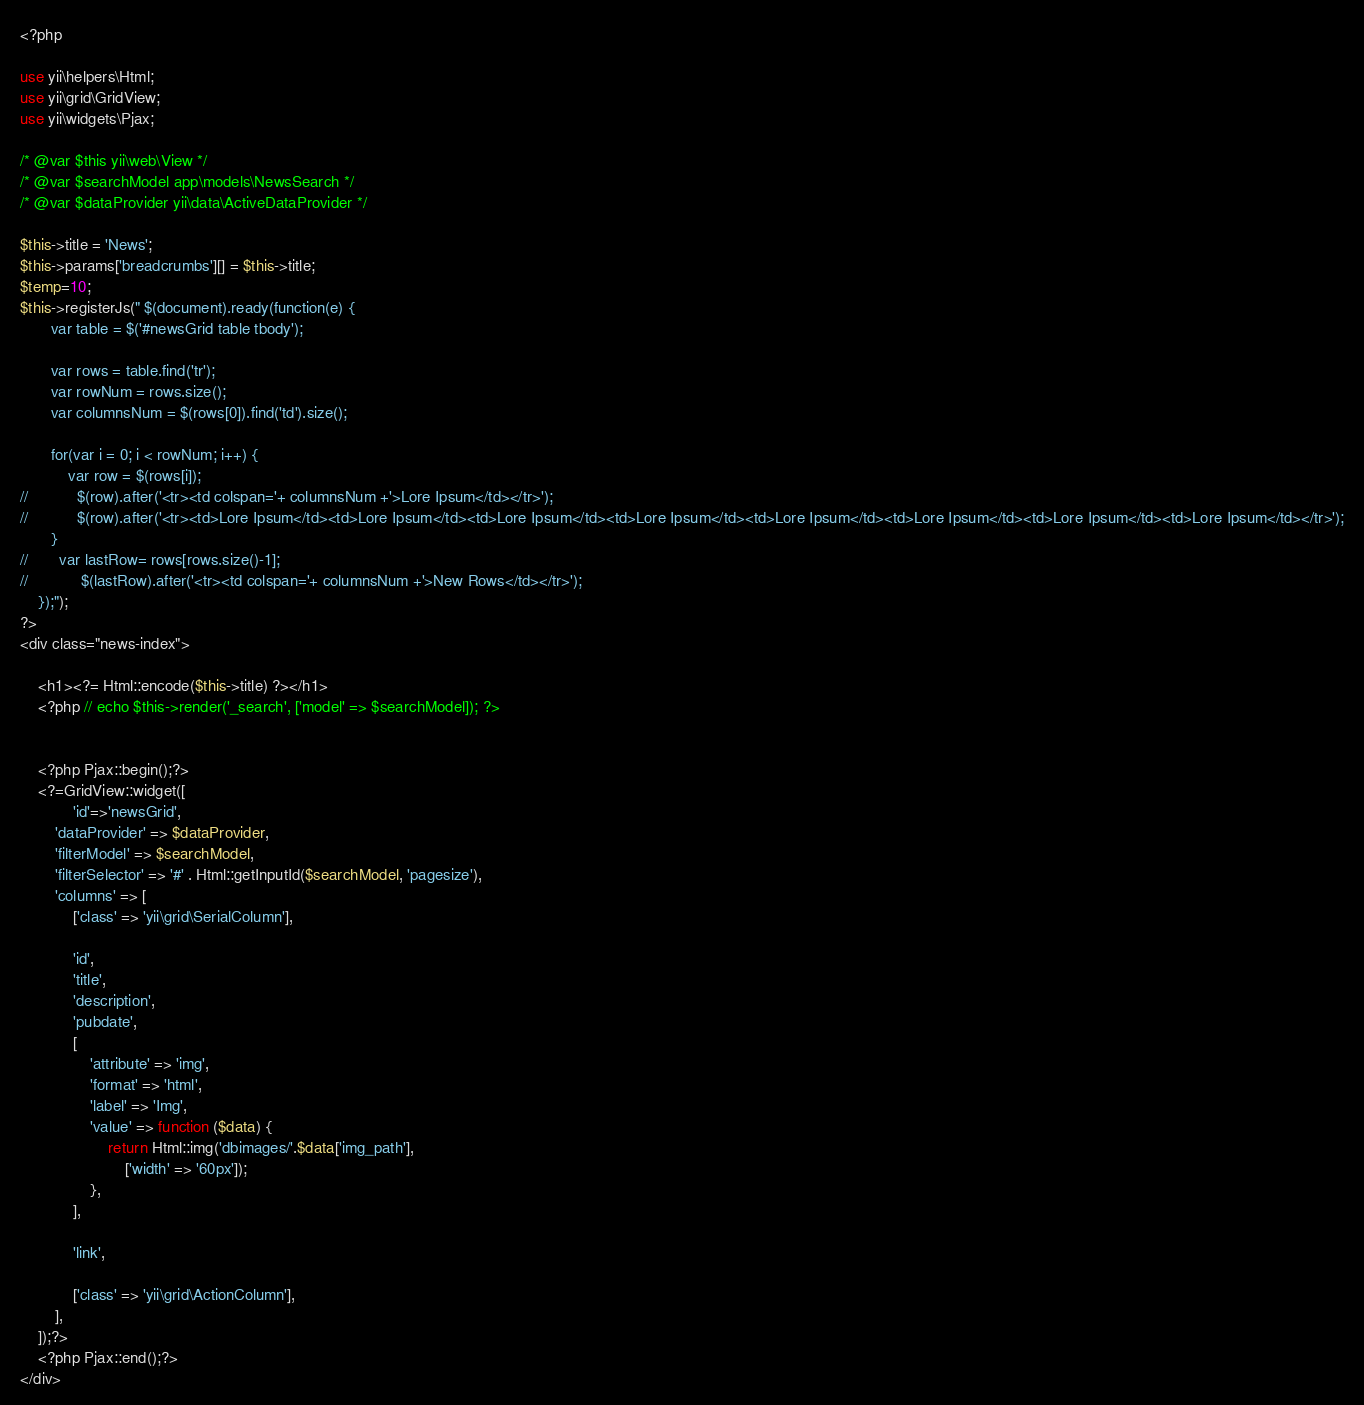<code> <loc_0><loc_0><loc_500><loc_500><_PHP_><?php

use yii\helpers\Html;
use yii\grid\GridView;
use yii\widgets\Pjax;

/* @var $this yii\web\View */
/* @var $searchModel app\models\NewsSearch */
/* @var $dataProvider yii\data\ActiveDataProvider */

$this->title = 'News';
$this->params['breadcrumbs'][] = $this->title;
$temp=10;
$this->registerJs(" $(document).ready(function(e) {
       var table = $('#newsGrid table tbody'); 

       var rows = table.find('tr');
       var rowNum = rows.size(); 
       var columnsNum = $(rows[0]).find('td').size(); 

       for(var i = 0; i < rowNum; i++) {
           var row = $(rows[i]);
//           $(row).after('<tr><td colspan='+ columnsNum +'>Lore Ipsum</td></tr>');
//           $(row).after('<tr><td>Lore Ipsum</td><td>Lore Ipsum</td><td>Lore Ipsum</td><td>Lore Ipsum</td><td>Lore Ipsum</td><td>Lore Ipsum</td><td>Lore Ipsum</td><td>Lore Ipsum</td></tr>');
       }   
//       var lastRow= rows[rows.size()-1];
//            $(lastRow).after('<tr><td colspan='+ columnsNum +'>New Rows</td></tr>');
    });");
?>
<div class="news-index">

    <h1><?= Html::encode($this->title) ?></h1>
    <?php // echo $this->render('_search', ['model' => $searchModel]); ?>


    <?php Pjax::begin();?>
    <?=GridView::widget([
            'id'=>'newsGrid',
        'dataProvider' => $dataProvider,
        'filterModel' => $searchModel,
        'filterSelector' => '#' . Html::getInputId($searchModel, 'pagesize'),
        'columns' => [
            ['class' => 'yii\grid\SerialColumn'],

            'id',
            'title',
            'description',
            'pubdate',
            [
                'attribute' => 'img',
                'format' => 'html',
                'label' => 'Img',
                'value' => function ($data) {
                    return Html::img('dbimages/'.$data['img_path'],
                        ['width' => '60px']);
                },
            ],

            'link',

            ['class' => 'yii\grid\ActionColumn'],
        ],
    ]);?>
    <?php Pjax::end();?>
</div>
</code> 